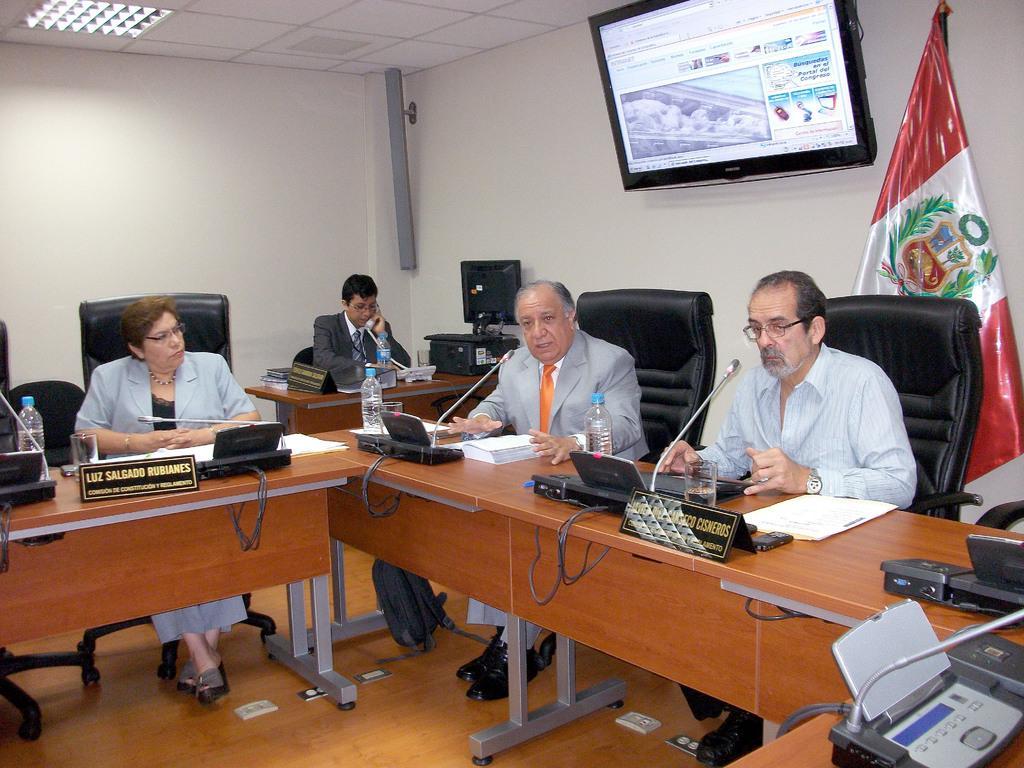Describe this image in one or two sentences. This picture there are some people sitting in front of a table on which a screen and a name plate along with some bottles and glasses were placed. There are some papers on the table. In the background there is a man standing, sorry sitting in front of a table. There is a television and a flag here. In the background there is a wall. 